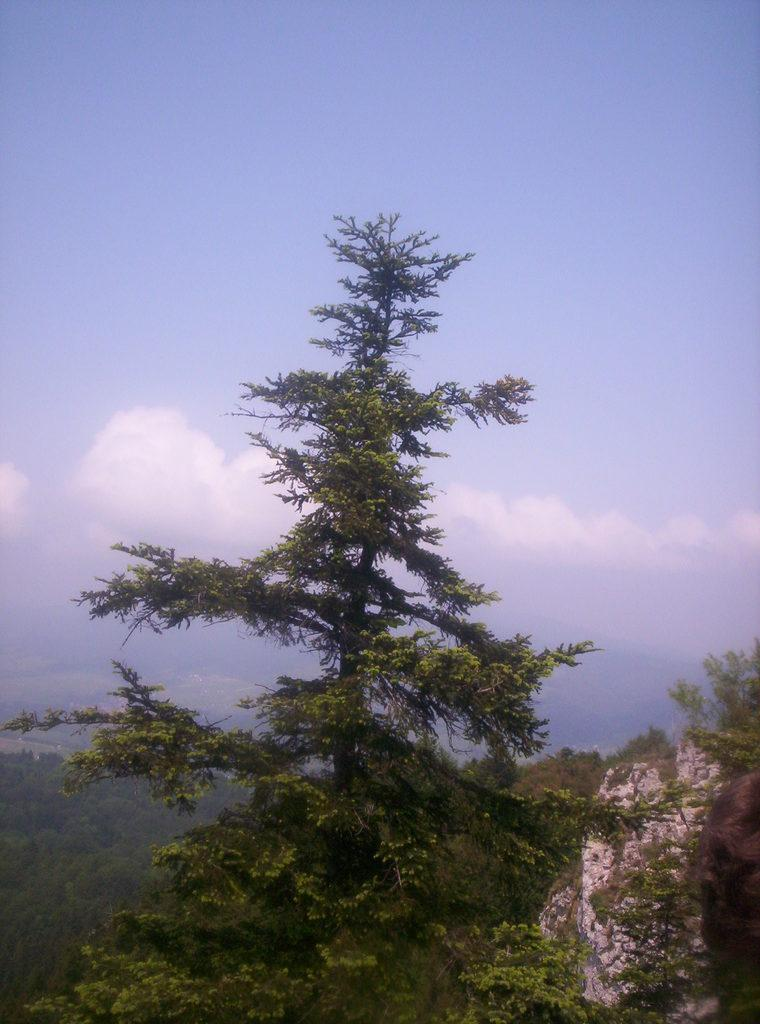What type of vegetation is at the bottom of the image? There are trees at the bottom of the image. What type of natural formation can be seen in the background of the image? There are mountains in the background of the image. What is visible in the sky in the image? There are clouds in the sky. What type of grape is being used as furniture in the image? There is no grape or furniture present in the image. Is the image showing a hot environment? The provided facts do not mention the temperature or heat in the image, so we cannot determine if it is hot or not. 